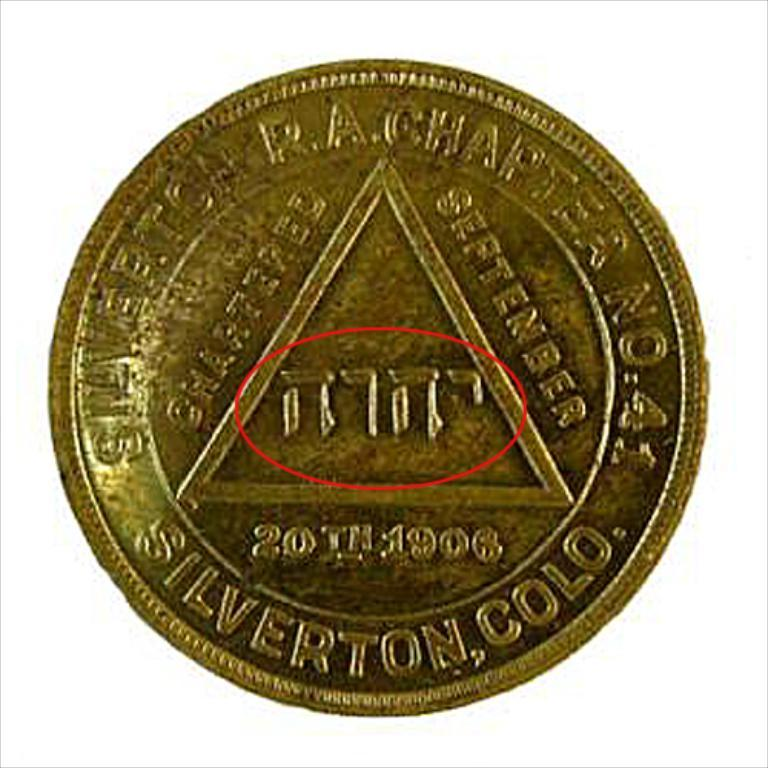What object is the main focus of the image? The main focus of the image is a coin. What can be found on the surface of the coin? The coin has text and structures on it. Is there a jail depicted on the coin in the image? No, there is no jail depicted on the coin in the image. Can you hear a drum playing in the background of the image? There is no sound or background noise mentioned in the image, so it is impossible to determine if a drum is playing. 